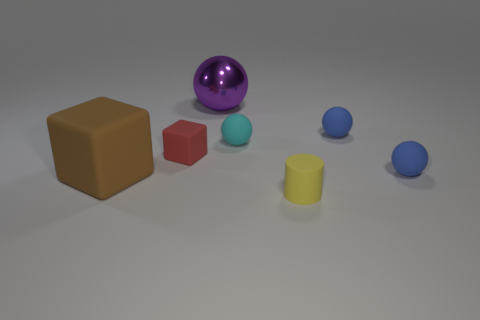Subtract all tiny balls. How many balls are left? 1 Subtract all cyan spheres. How many spheres are left? 3 Add 1 blue objects. How many objects exist? 8 Subtract all gray balls. Subtract all blue cylinders. How many balls are left? 4 Subtract all cubes. How many objects are left? 5 Add 3 big green shiny cylinders. How many big green shiny cylinders exist? 3 Subtract 0 yellow balls. How many objects are left? 7 Subtract all tiny red matte things. Subtract all big brown rubber things. How many objects are left? 5 Add 7 big purple metallic objects. How many big purple metallic objects are left? 8 